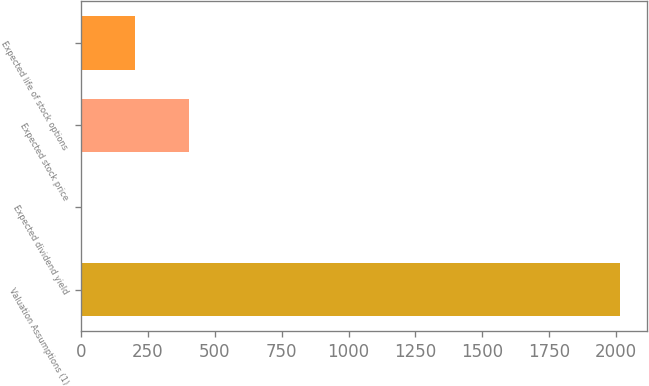<chart> <loc_0><loc_0><loc_500><loc_500><bar_chart><fcel>Valuation Assumptions (1)<fcel>Expected dividend yield<fcel>Expected stock price<fcel>Expected life of stock options<nl><fcel>2014<fcel>2<fcel>404.4<fcel>203.2<nl></chart> 